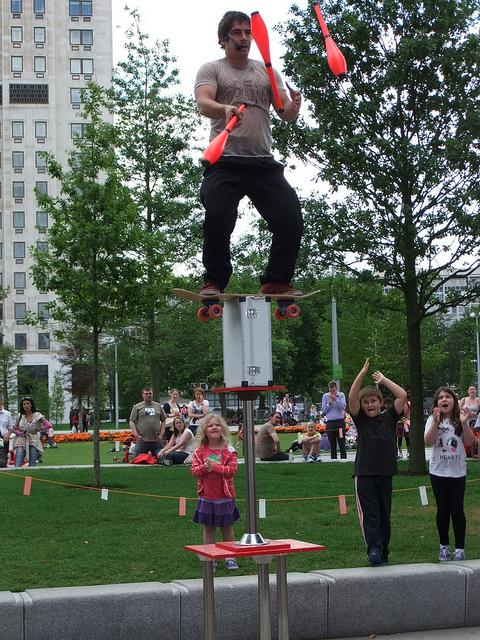How many pins are juggled up on top of the post by the man standing on the skateboard?

Choices:
A) three
B) six
C) one
D) four three 